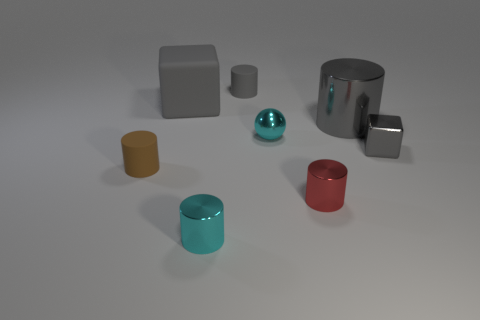What is the block to the left of the red metal cylinder made of?
Your response must be concise. Rubber. Are the cube behind the small ball and the tiny brown object on the left side of the gray rubber cylinder made of the same material?
Provide a succinct answer. Yes. Are there the same number of gray cylinders in front of the small metal cube and gray objects that are in front of the tiny metallic sphere?
Offer a very short reply. No. How many cylinders have the same material as the cyan ball?
Offer a very short reply. 3. What shape is the object that is the same color as the small ball?
Make the answer very short. Cylinder. There is a cyan object in front of the matte object that is to the left of the big matte thing; what size is it?
Your response must be concise. Small. Does the cyan thing that is in front of the small gray shiny block have the same shape as the tiny gray thing left of the tiny gray cube?
Offer a terse response. Yes. Are there an equal number of cyan spheres left of the gray matte cube and large objects?
Keep it short and to the point. No. There is another small shiny object that is the same shape as the tiny red object; what color is it?
Ensure brevity in your answer.  Cyan. Do the cube in front of the big rubber block and the small cyan ball have the same material?
Make the answer very short. Yes. 